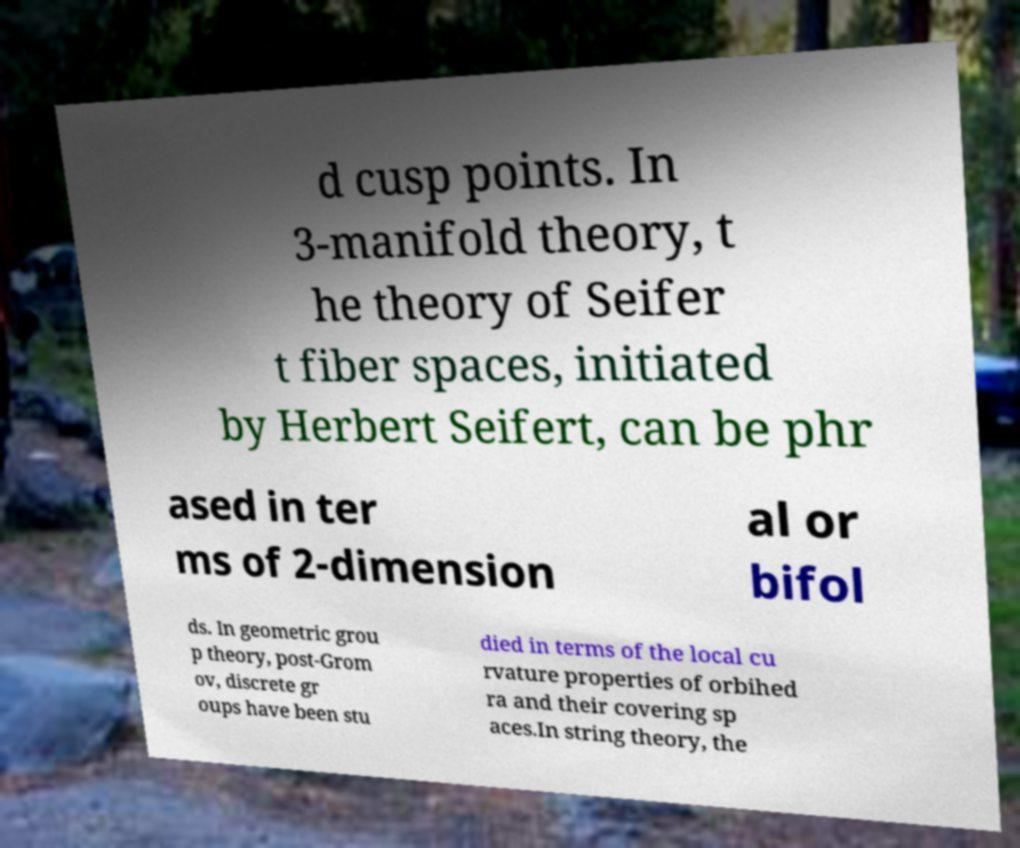Could you extract and type out the text from this image? d cusp points. In 3-manifold theory, t he theory of Seifer t fiber spaces, initiated by Herbert Seifert, can be phr ased in ter ms of 2-dimension al or bifol ds. In geometric grou p theory, post-Grom ov, discrete gr oups have been stu died in terms of the local cu rvature properties of orbihed ra and their covering sp aces.In string theory, the 